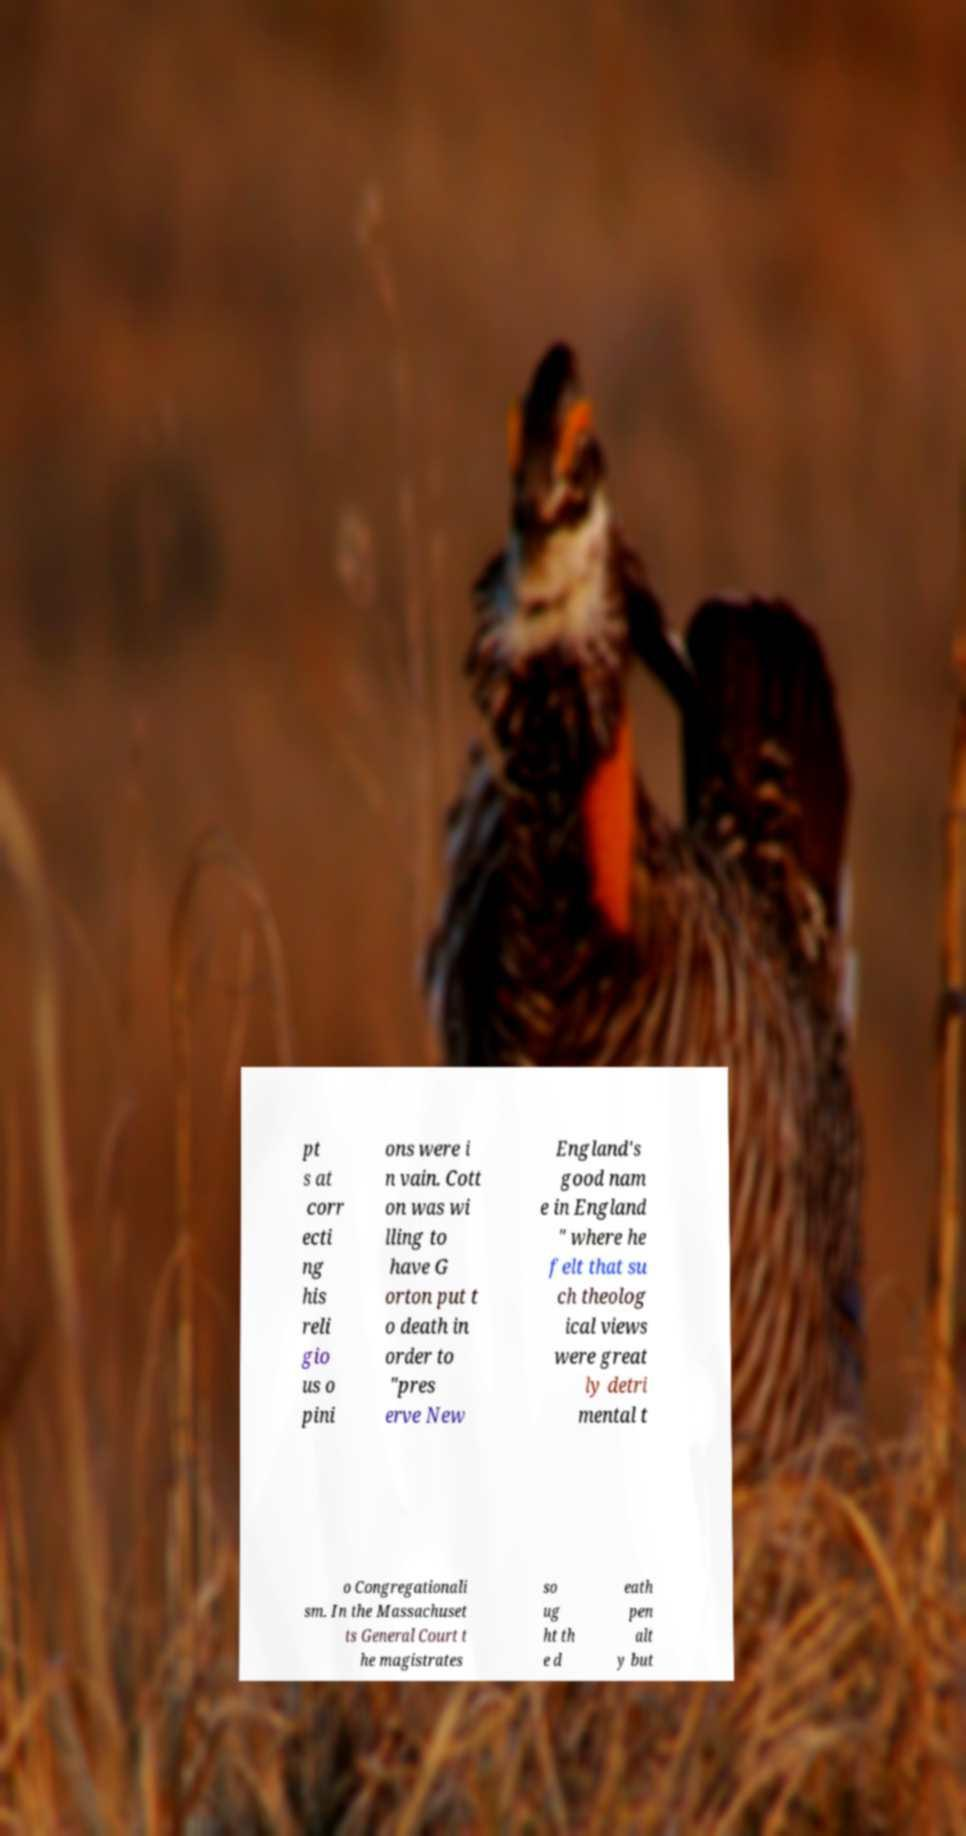What messages or text are displayed in this image? I need them in a readable, typed format. pt s at corr ecti ng his reli gio us o pini ons were i n vain. Cott on was wi lling to have G orton put t o death in order to "pres erve New England's good nam e in England " where he felt that su ch theolog ical views were great ly detri mental t o Congregationali sm. In the Massachuset ts General Court t he magistrates so ug ht th e d eath pen alt y but 